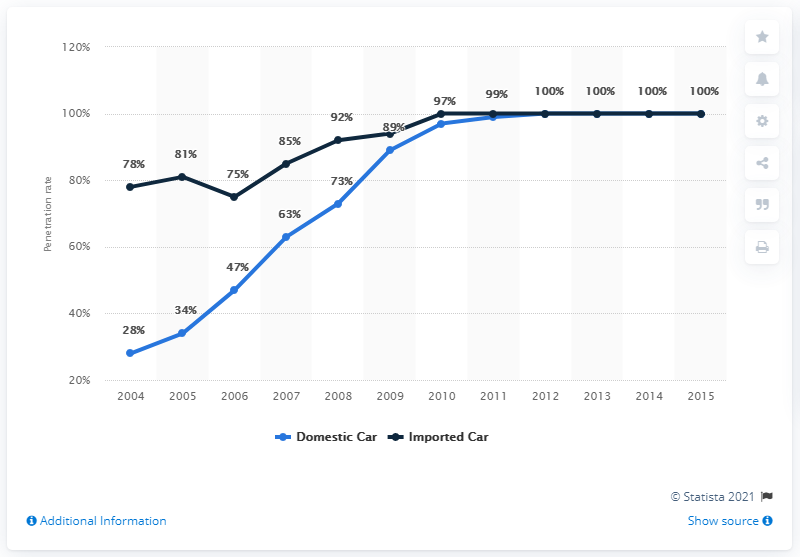Outline some significant characteristics in this image. The penetration rate of side airbags in the US began to increase in the year 2004. The penetration rate of side airbags in the United States increased from 100% from 2004 to 2012. 